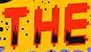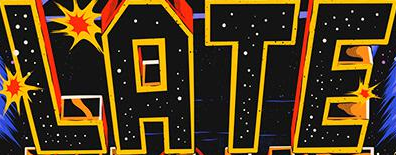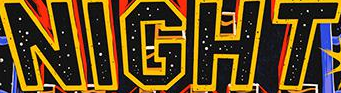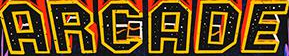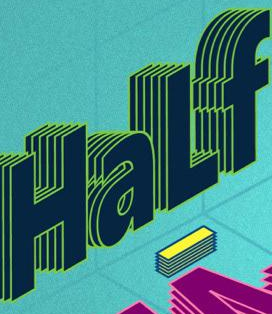What text is displayed in these images sequentially, separated by a semicolon? THE; LATE; NIGHT; ARGADE; HaLf 